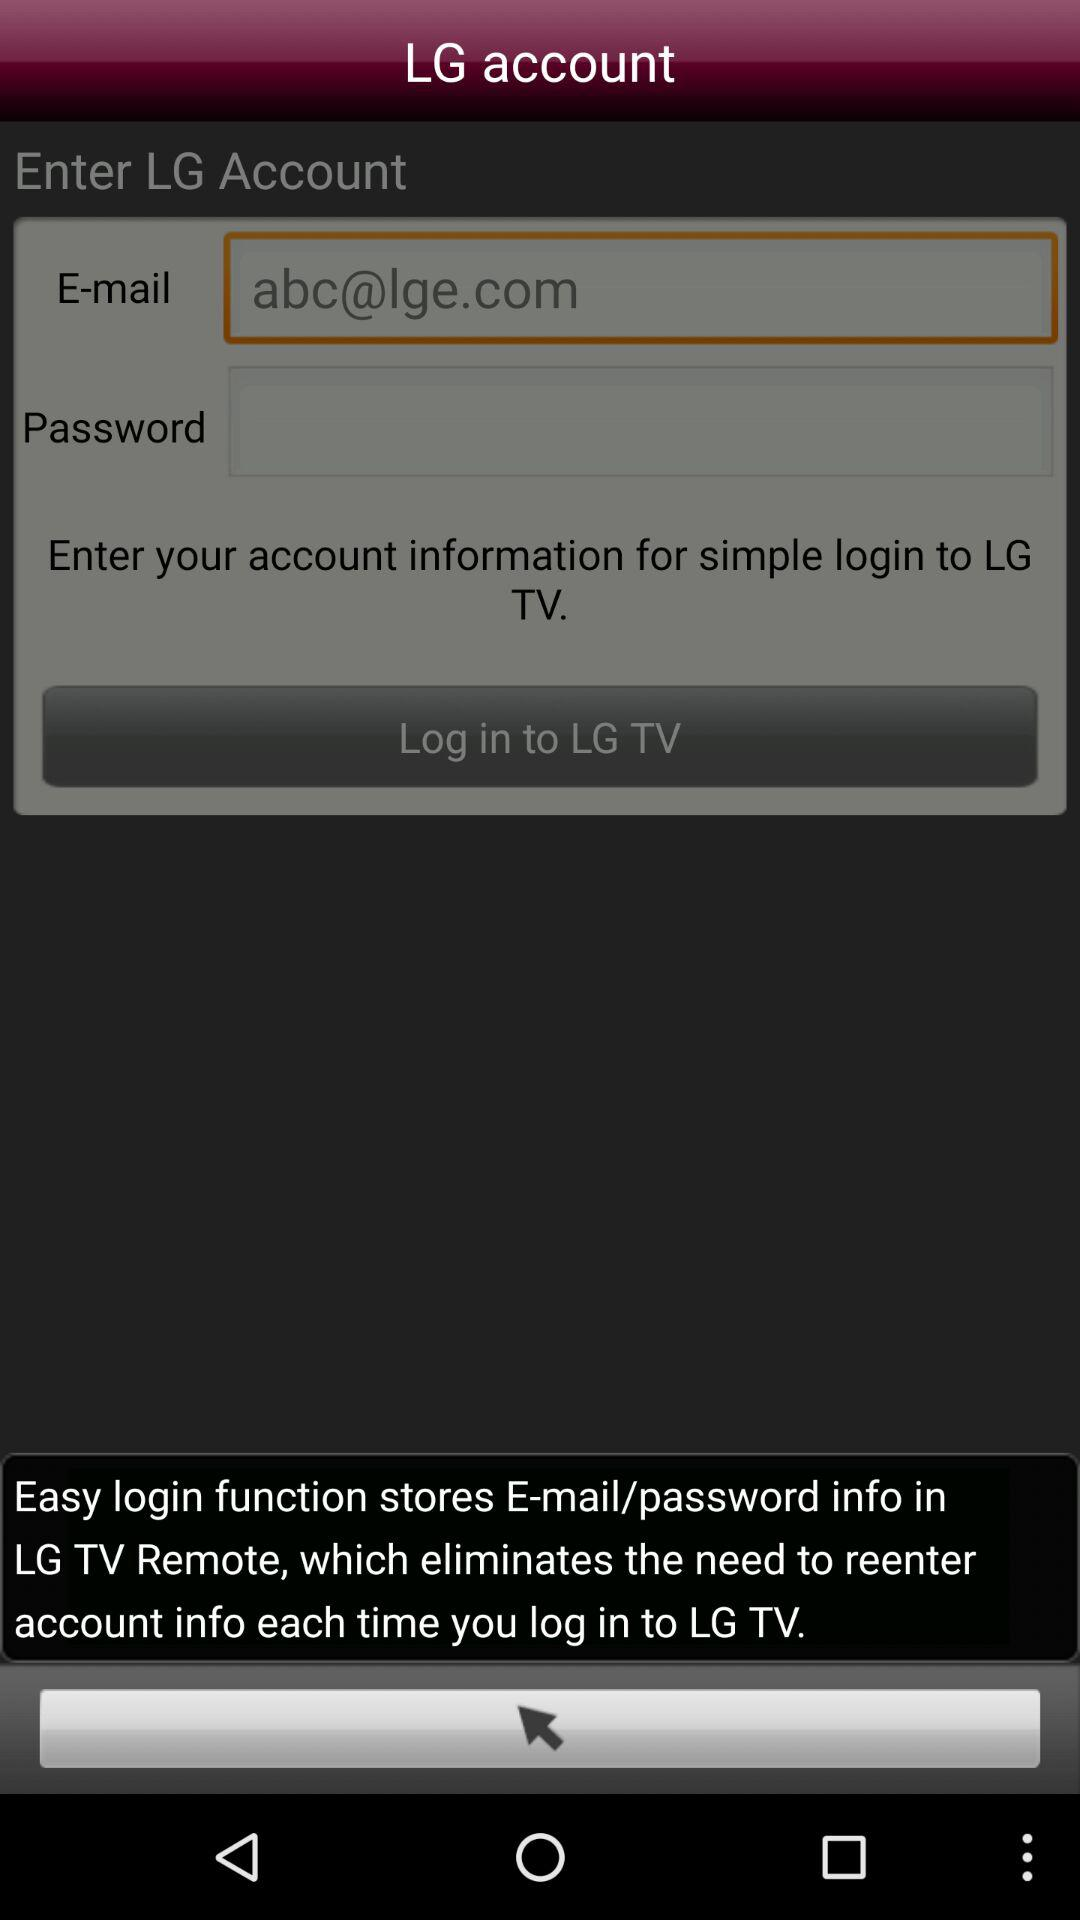What is the email address? The email address is abc@lge.com. 